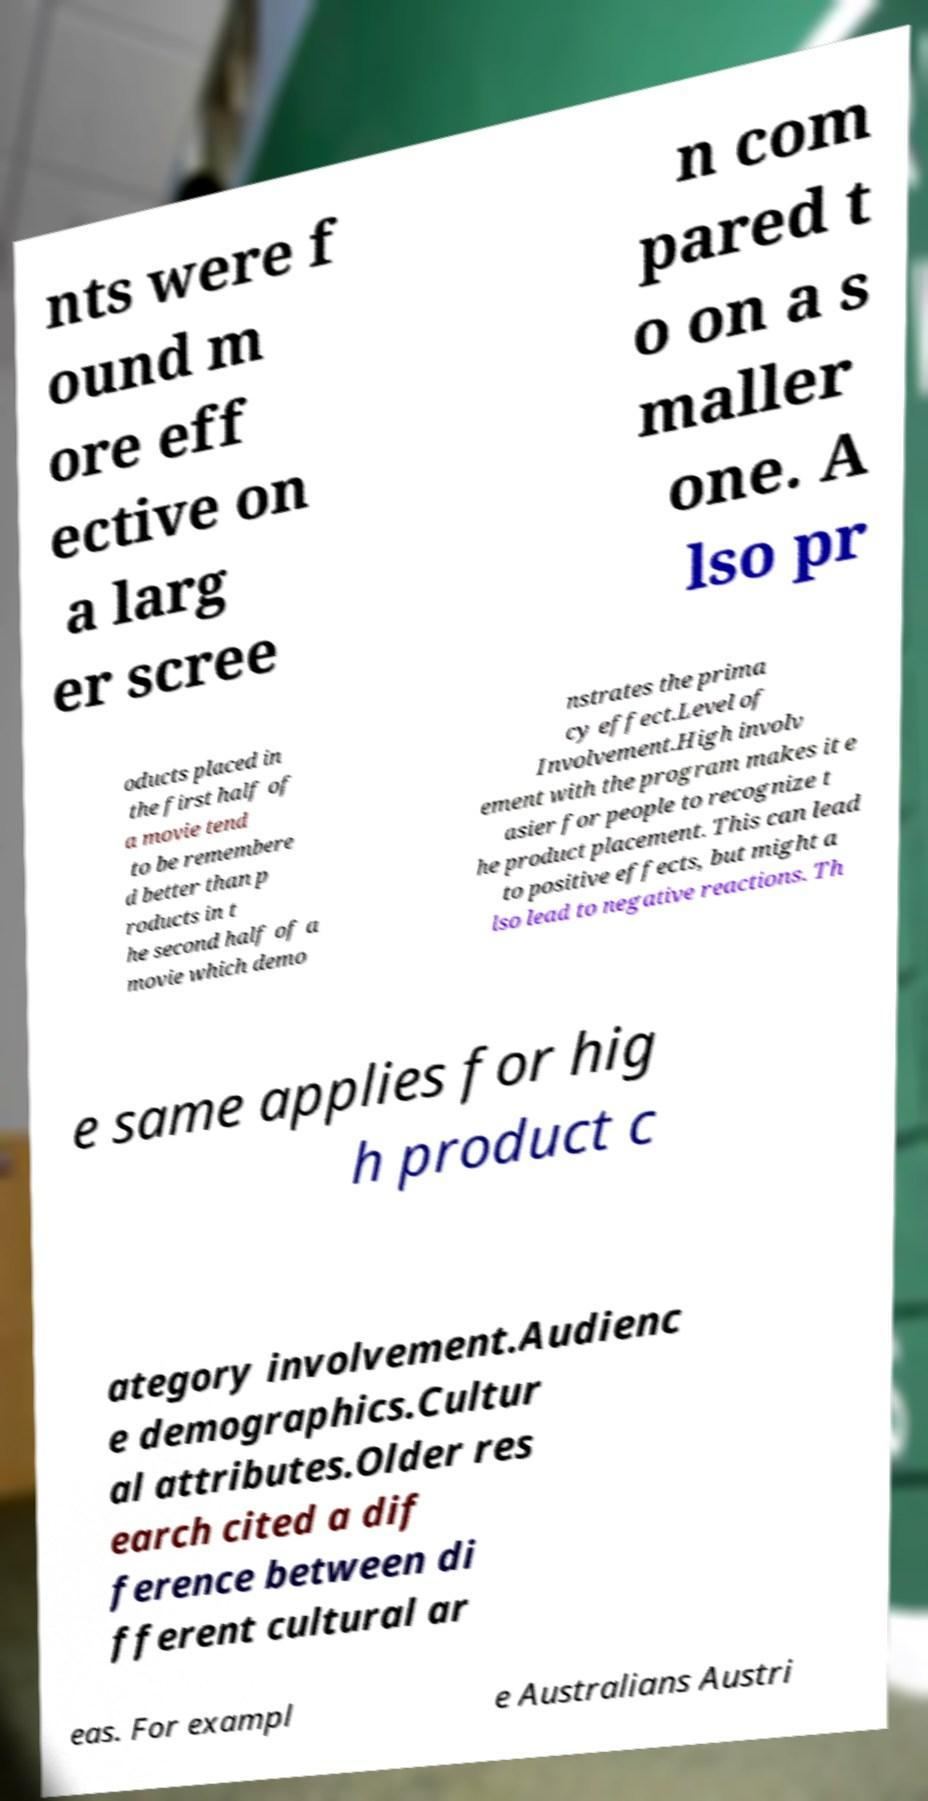I need the written content from this picture converted into text. Can you do that? nts were f ound m ore eff ective on a larg er scree n com pared t o on a s maller one. A lso pr oducts placed in the first half of a movie tend to be remembere d better than p roducts in t he second half of a movie which demo nstrates the prima cy effect.Level of Involvement.High involv ement with the program makes it e asier for people to recognize t he product placement. This can lead to positive effects, but might a lso lead to negative reactions. Th e same applies for hig h product c ategory involvement.Audienc e demographics.Cultur al attributes.Older res earch cited a dif ference between di fferent cultural ar eas. For exampl e Australians Austri 